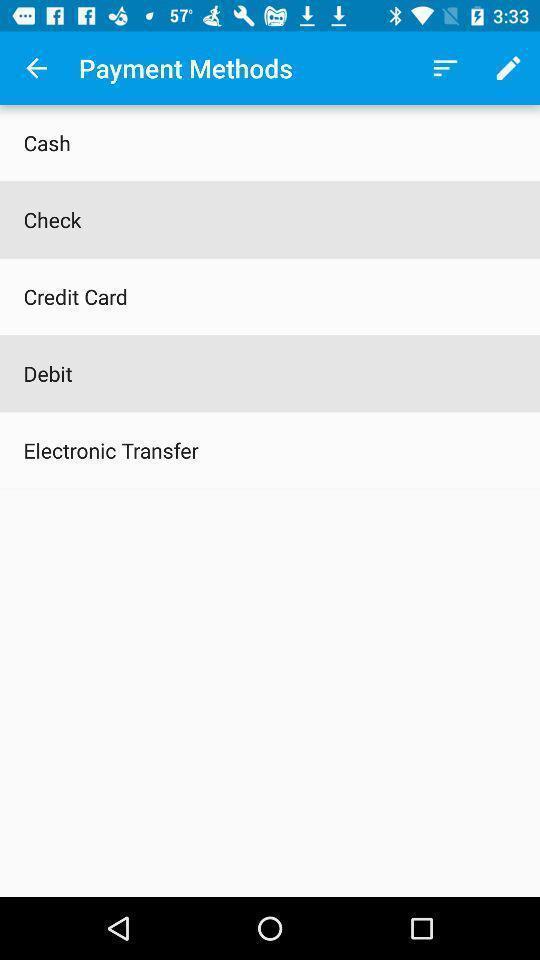Provide a description of this screenshot. Screen shows list of payment methods. 